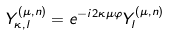<formula> <loc_0><loc_0><loc_500><loc_500>Y _ { \kappa , l } ^ { ( \mu , n ) } = e ^ { - i 2 \kappa \mu \varphi } Y _ { l } ^ { ( \mu , n ) }</formula> 